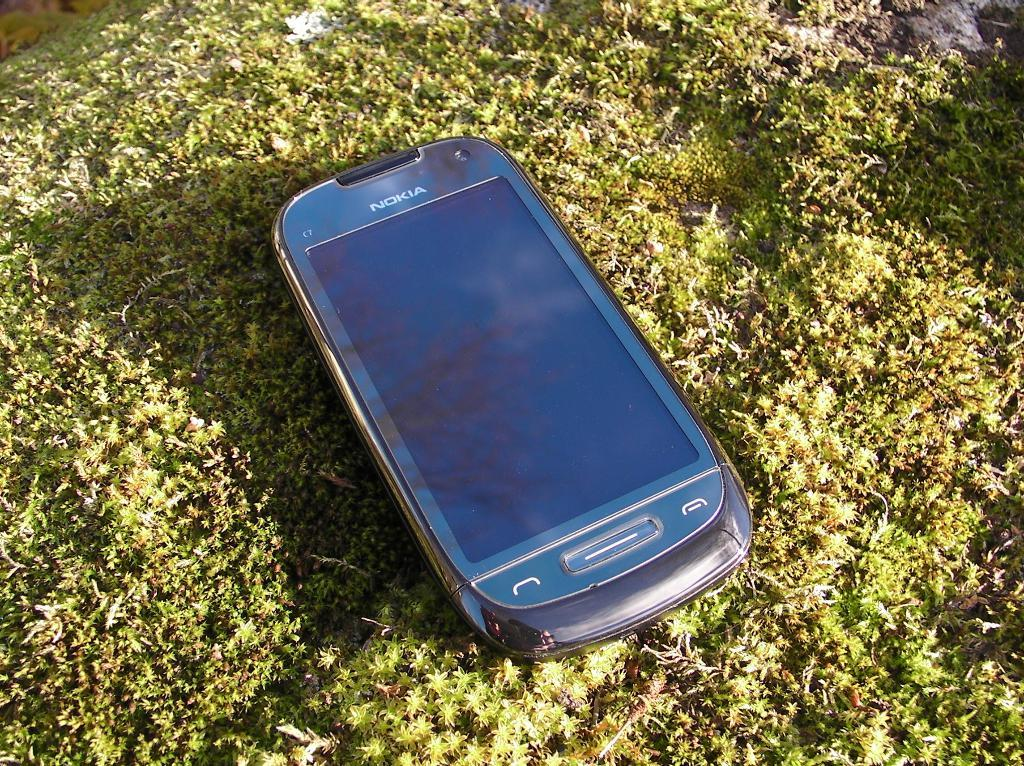<image>
Create a compact narrative representing the image presented. A Nokia cell phone that appears to be off is sitting on some moss. 